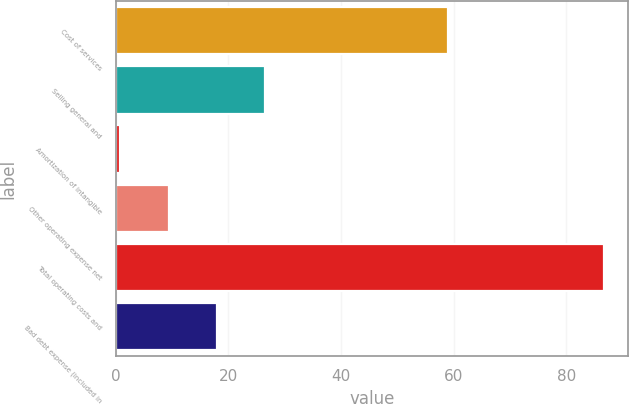Convert chart. <chart><loc_0><loc_0><loc_500><loc_500><bar_chart><fcel>Cost of services<fcel>Selling general and<fcel>Amortization of intangible<fcel>Other operating expense net<fcel>Total operating costs and<fcel>Bad debt expense (included in<nl><fcel>59<fcel>26.54<fcel>0.8<fcel>9.38<fcel>86.6<fcel>17.96<nl></chart> 